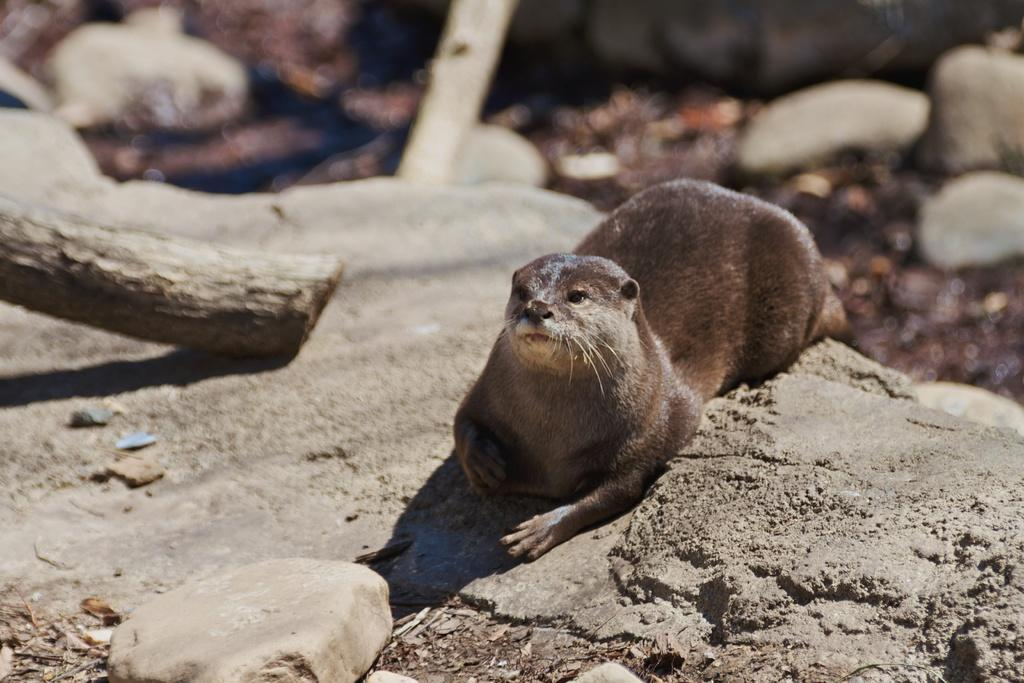What type of animal is in the image? There is an animal in the image, but the specific type cannot be determined from the provided facts. Can you describe the coloring of the animal? The animal has black, brown, and cream coloring. Where is the animal located in the image? The animal is on a rocky surface. What other objects can be seen in the image? There is a wooden log in the image. How would you characterize the background of the image? The background of the image is blurry and there are rocks visible in the background. How does the animal plan to join the stick-making competition in the image? There is no indication in the image that the animal is participating in a stick-making competition or has any intention of joining one. What type of mask is the animal wearing in the image? There is no mask present in the image; the animal has black, brown, and cream coloring. 